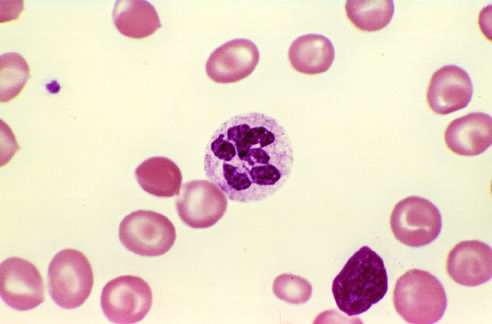what shows a hyper-segmented neutrophil with a six-lobed nucleus?
Answer the question using a single word or phrase. A peripheral blood smear 